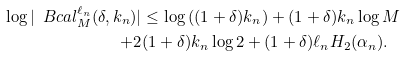<formula> <loc_0><loc_0><loc_500><loc_500>\log | \ B c a l _ { M } ^ { \ell _ { n } } ( \delta , k _ { n } ) | & \leq \log \left ( ( 1 + \delta ) k _ { n } \right ) + ( 1 + \delta ) k _ { n } \log M \\ + 2 & ( 1 + \delta ) k _ { n } \log 2 + ( 1 + \delta ) \ell _ { n } H _ { 2 } ( \alpha _ { n } ) .</formula> 